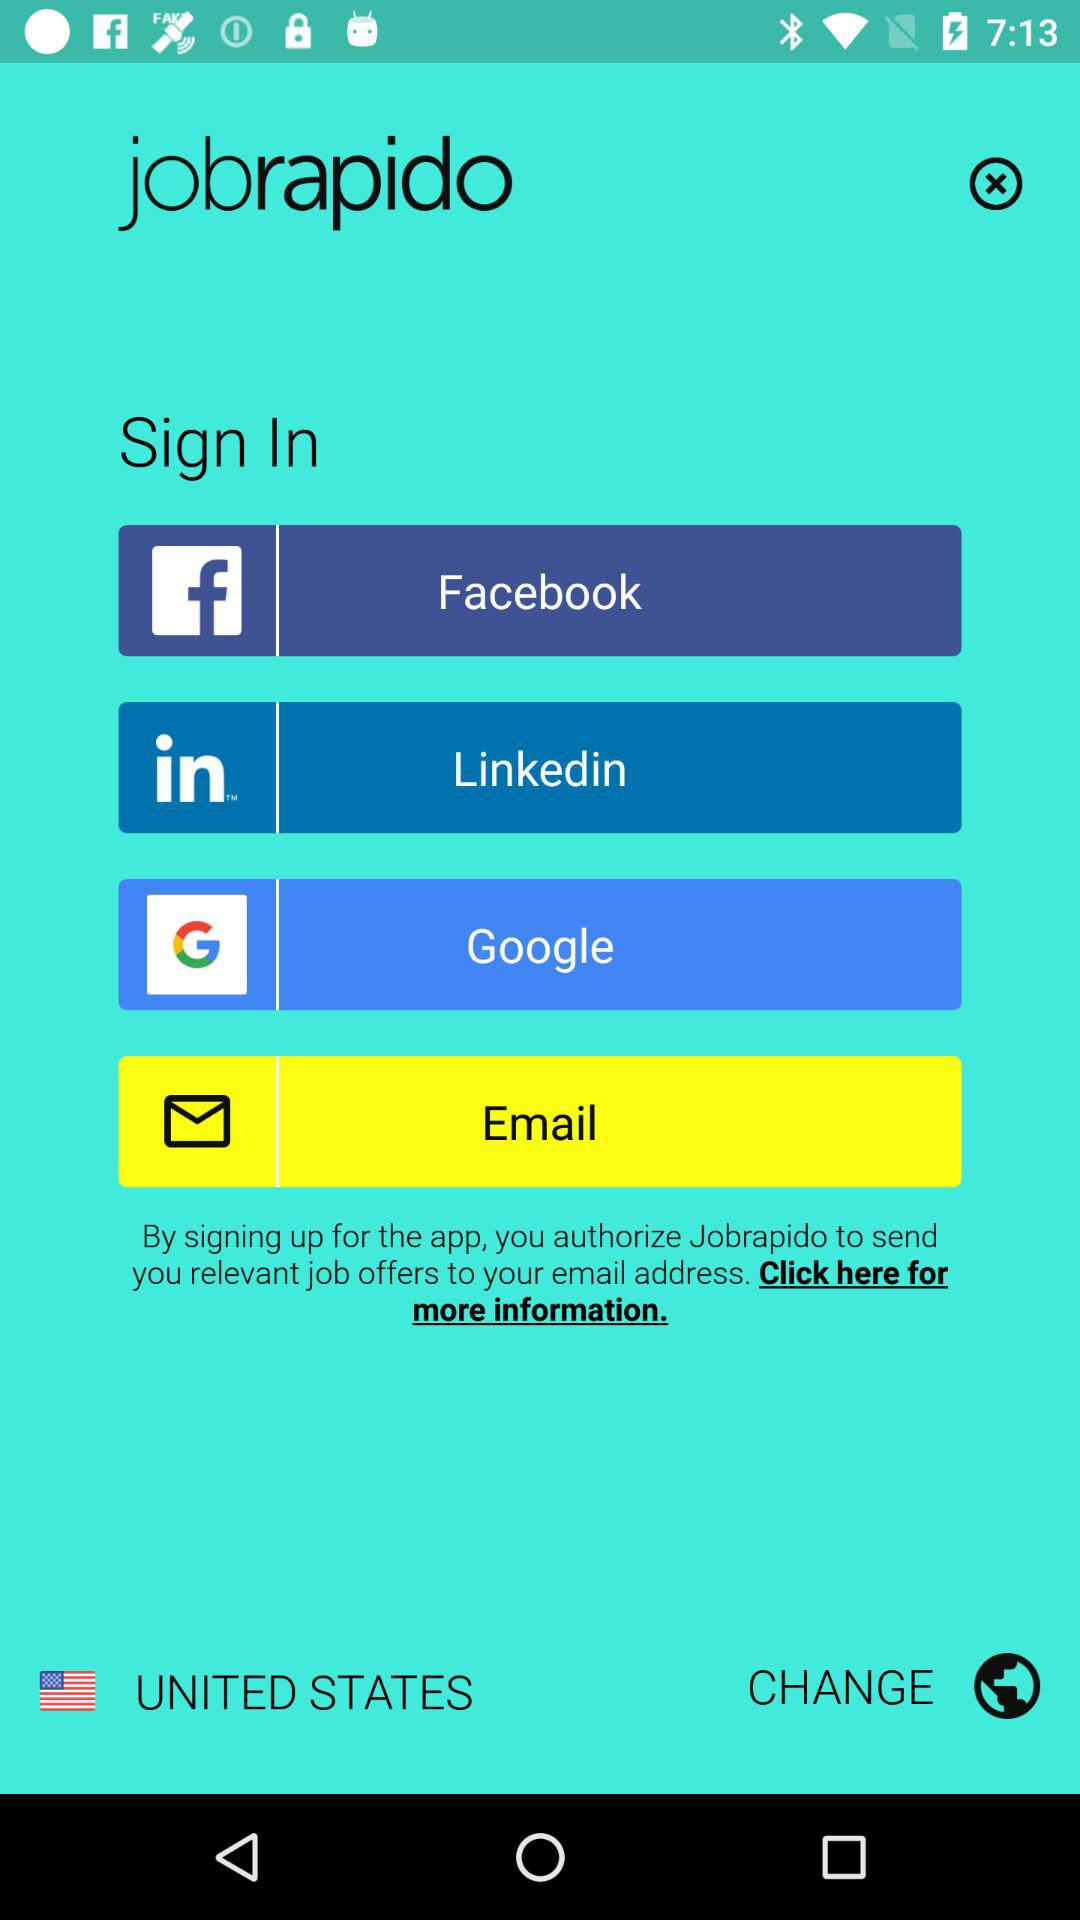What is the application name? The application name is "jobrapido". 